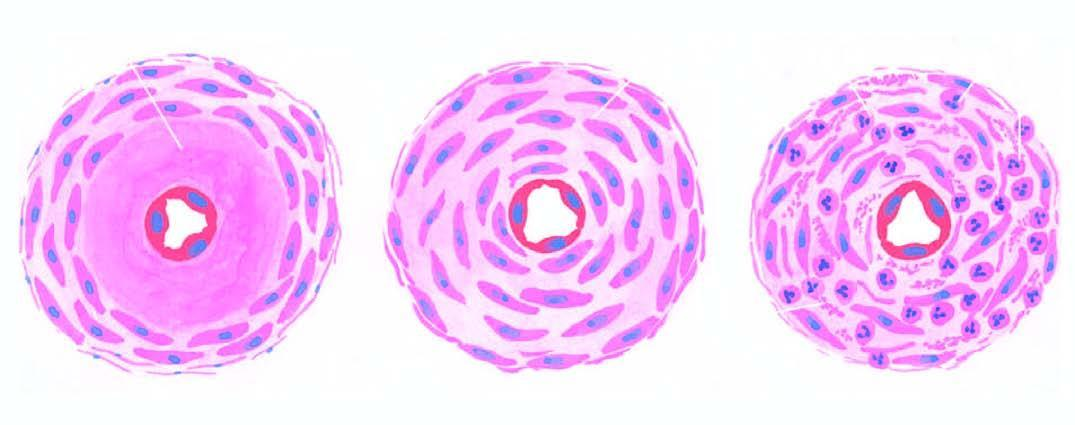s ziehl-neelsen or afb seen in hypertension?
Answer the question using a single word or phrase. No 